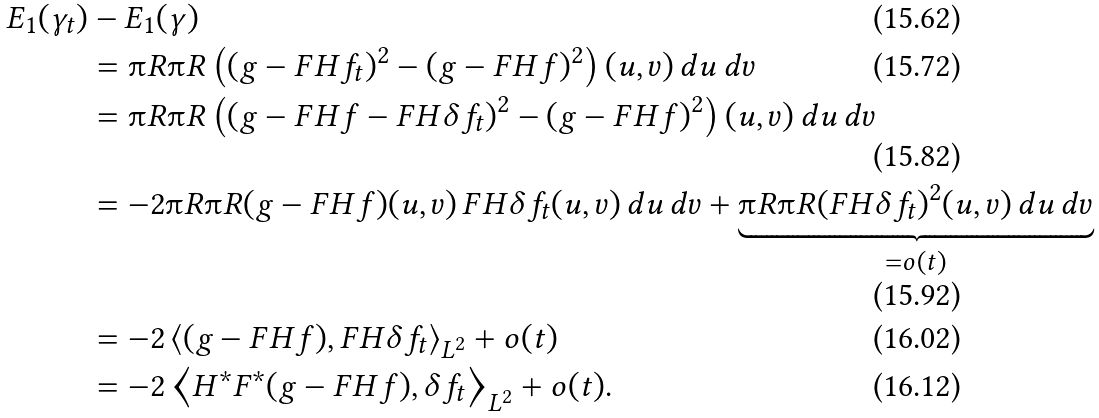<formula> <loc_0><loc_0><loc_500><loc_500>E _ { 1 } ( \gamma _ { t } ) & - E _ { 1 } ( \gamma ) \\ & = \i R \i R \left ( ( g - F H f _ { t } ) ^ { 2 } - ( g - F H f ) ^ { 2 } \right ) ( u , v ) \, d u \, d v \\ & = \i R \i R \left ( ( g - F H f - F H \delta f _ { t } ) ^ { 2 } - ( g - F H f ) ^ { 2 } \right ) ( u , v ) \, d u \, d v \\ & = - 2 \i R \i R ( g - F H f ) ( u , v ) \, F H \delta f _ { t } ( u , v ) \, d u \, d v + \underbrace { \i R \i R ( F H \delta f _ { t } ) ^ { 2 } ( u , v ) \, d u \, d v } _ { = o ( t ) } \\ & = - 2 \left < ( g - F H f ) , F H \delta f _ { t } \right > _ { L ^ { 2 } } + o ( t ) \\ & = - 2 \left < H ^ { * } F ^ { * } ( g - F H f ) , \delta f _ { t } \right > _ { L ^ { 2 } } + o ( t ) .</formula> 